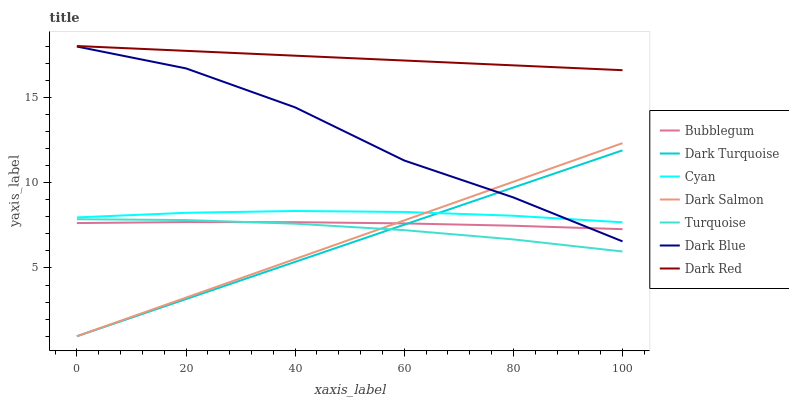Does Dark Turquoise have the minimum area under the curve?
Answer yes or no. Yes. Does Dark Red have the maximum area under the curve?
Answer yes or no. Yes. Does Dark Salmon have the minimum area under the curve?
Answer yes or no. No. Does Dark Salmon have the maximum area under the curve?
Answer yes or no. No. Is Dark Turquoise the smoothest?
Answer yes or no. Yes. Is Dark Blue the roughest?
Answer yes or no. Yes. Is Bubblegum the smoothest?
Answer yes or no. No. Is Bubblegum the roughest?
Answer yes or no. No. Does Dark Turquoise have the lowest value?
Answer yes or no. Yes. Does Bubblegum have the lowest value?
Answer yes or no. No. Does Dark Red have the highest value?
Answer yes or no. Yes. Does Dark Turquoise have the highest value?
Answer yes or no. No. Is Turquoise less than Dark Red?
Answer yes or no. Yes. Is Dark Red greater than Dark Salmon?
Answer yes or no. Yes. Does Dark Blue intersect Bubblegum?
Answer yes or no. Yes. Is Dark Blue less than Bubblegum?
Answer yes or no. No. Is Dark Blue greater than Bubblegum?
Answer yes or no. No. Does Turquoise intersect Dark Red?
Answer yes or no. No. 